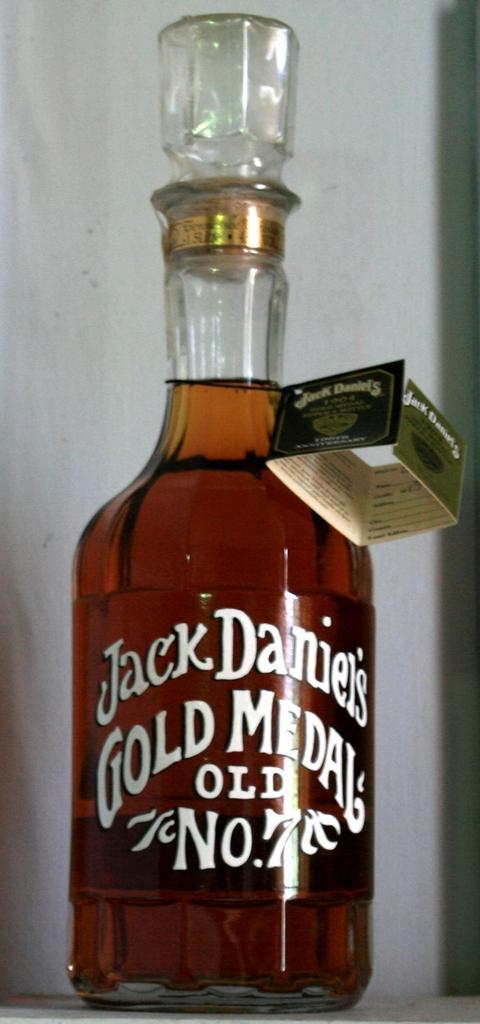Please provide a concise description of this image. In this image i can see a wine glass bottle. 